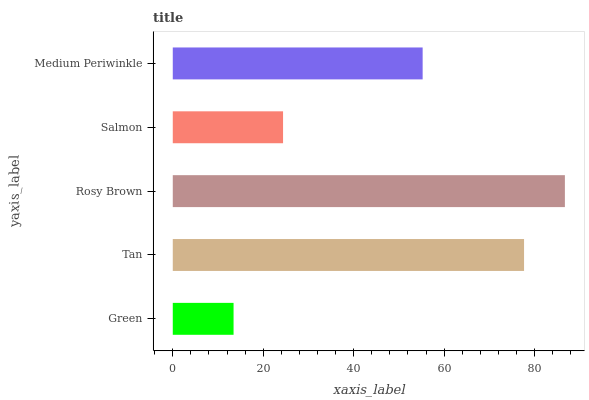Is Green the minimum?
Answer yes or no. Yes. Is Rosy Brown the maximum?
Answer yes or no. Yes. Is Tan the minimum?
Answer yes or no. No. Is Tan the maximum?
Answer yes or no. No. Is Tan greater than Green?
Answer yes or no. Yes. Is Green less than Tan?
Answer yes or no. Yes. Is Green greater than Tan?
Answer yes or no. No. Is Tan less than Green?
Answer yes or no. No. Is Medium Periwinkle the high median?
Answer yes or no. Yes. Is Medium Periwinkle the low median?
Answer yes or no. Yes. Is Green the high median?
Answer yes or no. No. Is Salmon the low median?
Answer yes or no. No. 